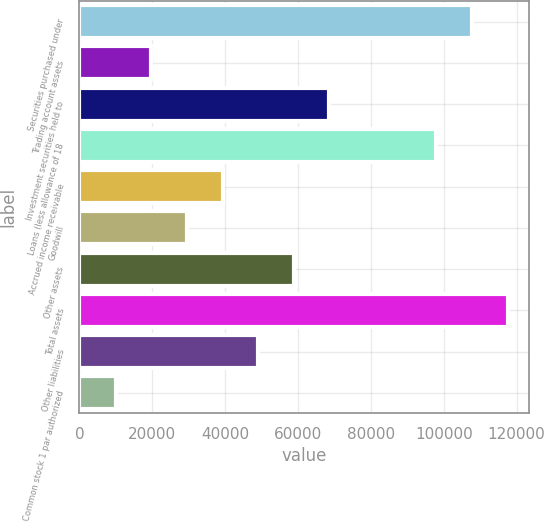<chart> <loc_0><loc_0><loc_500><loc_500><bar_chart><fcel>Securities purchased under<fcel>Trading account assets<fcel>Investment securities held to<fcel>Loans (less allowance of 18<fcel>Accrued income receivable<fcel>Goodwill<fcel>Other assets<fcel>Total assets<fcel>Other liabilities<fcel>Common stock 1 par authorized<nl><fcel>107745<fcel>19748.8<fcel>68635.8<fcel>97968<fcel>39303.6<fcel>29526.2<fcel>58858.4<fcel>117523<fcel>49081<fcel>9971.4<nl></chart> 